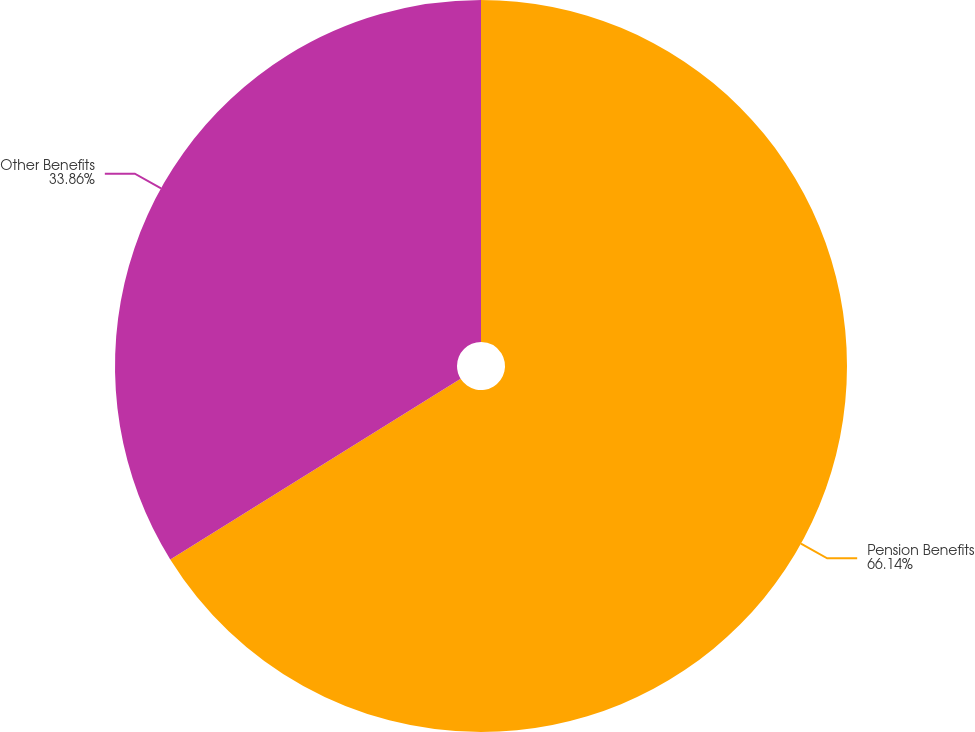Convert chart. <chart><loc_0><loc_0><loc_500><loc_500><pie_chart><fcel>Pension Benefits<fcel>Other Benefits<nl><fcel>66.14%<fcel>33.86%<nl></chart> 